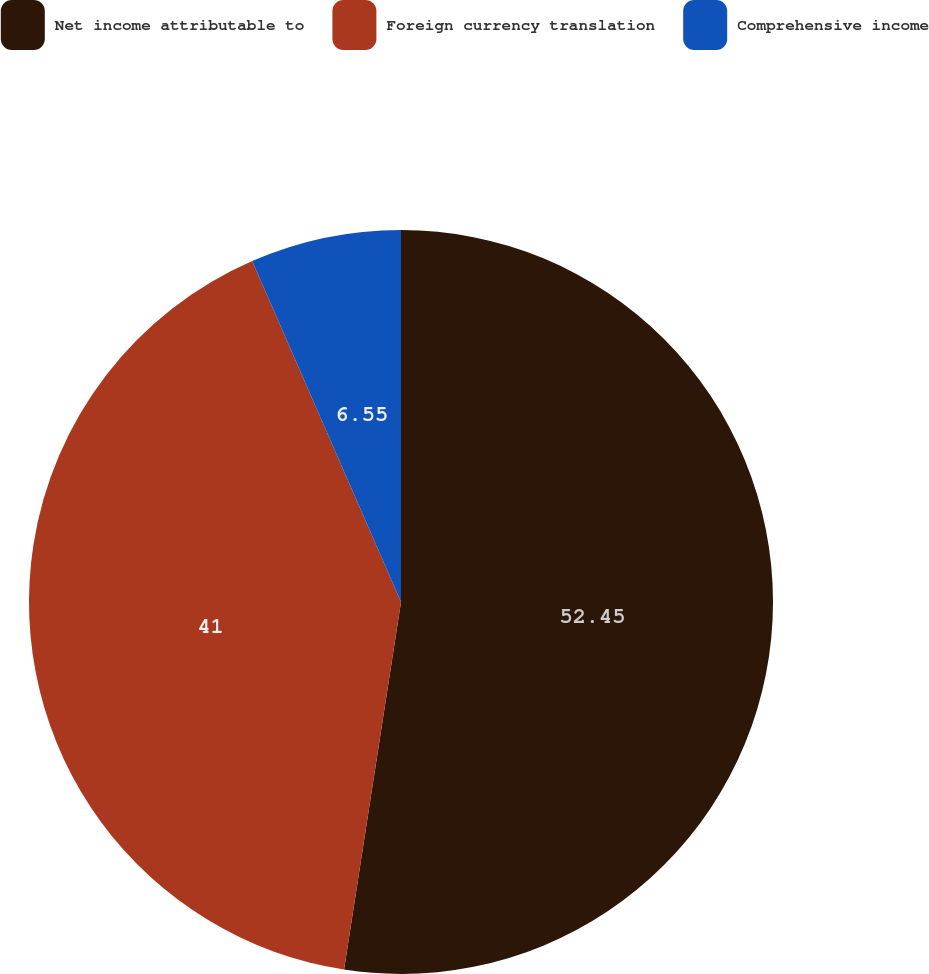Convert chart. <chart><loc_0><loc_0><loc_500><loc_500><pie_chart><fcel>Net income attributable to<fcel>Foreign currency translation<fcel>Comprehensive income<nl><fcel>52.44%<fcel>41.0%<fcel>6.55%<nl></chart> 